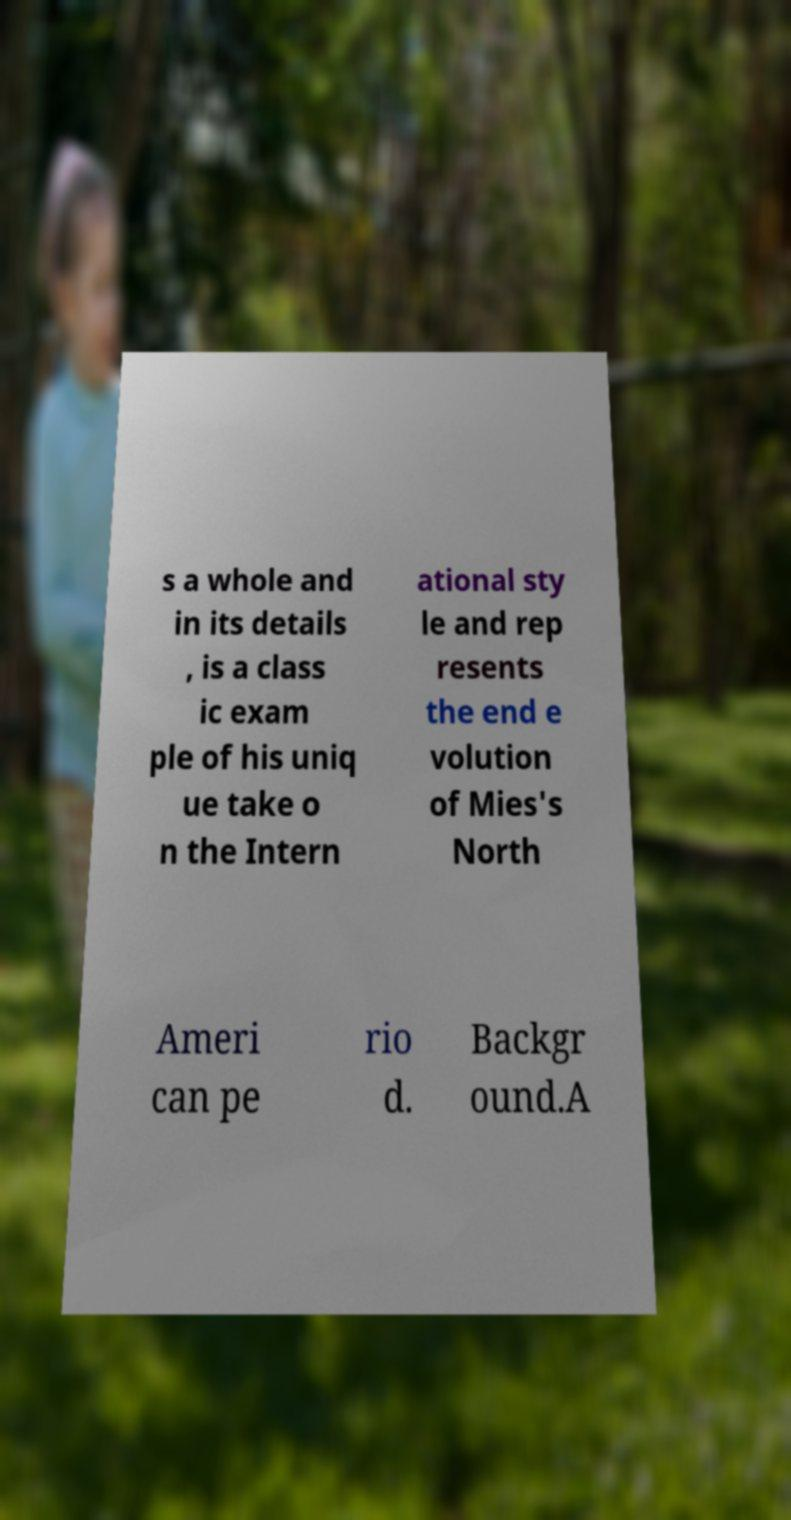Please identify and transcribe the text found in this image. s a whole and in its details , is a class ic exam ple of his uniq ue take o n the Intern ational sty le and rep resents the end e volution of Mies's North Ameri can pe rio d. Backgr ound.A 